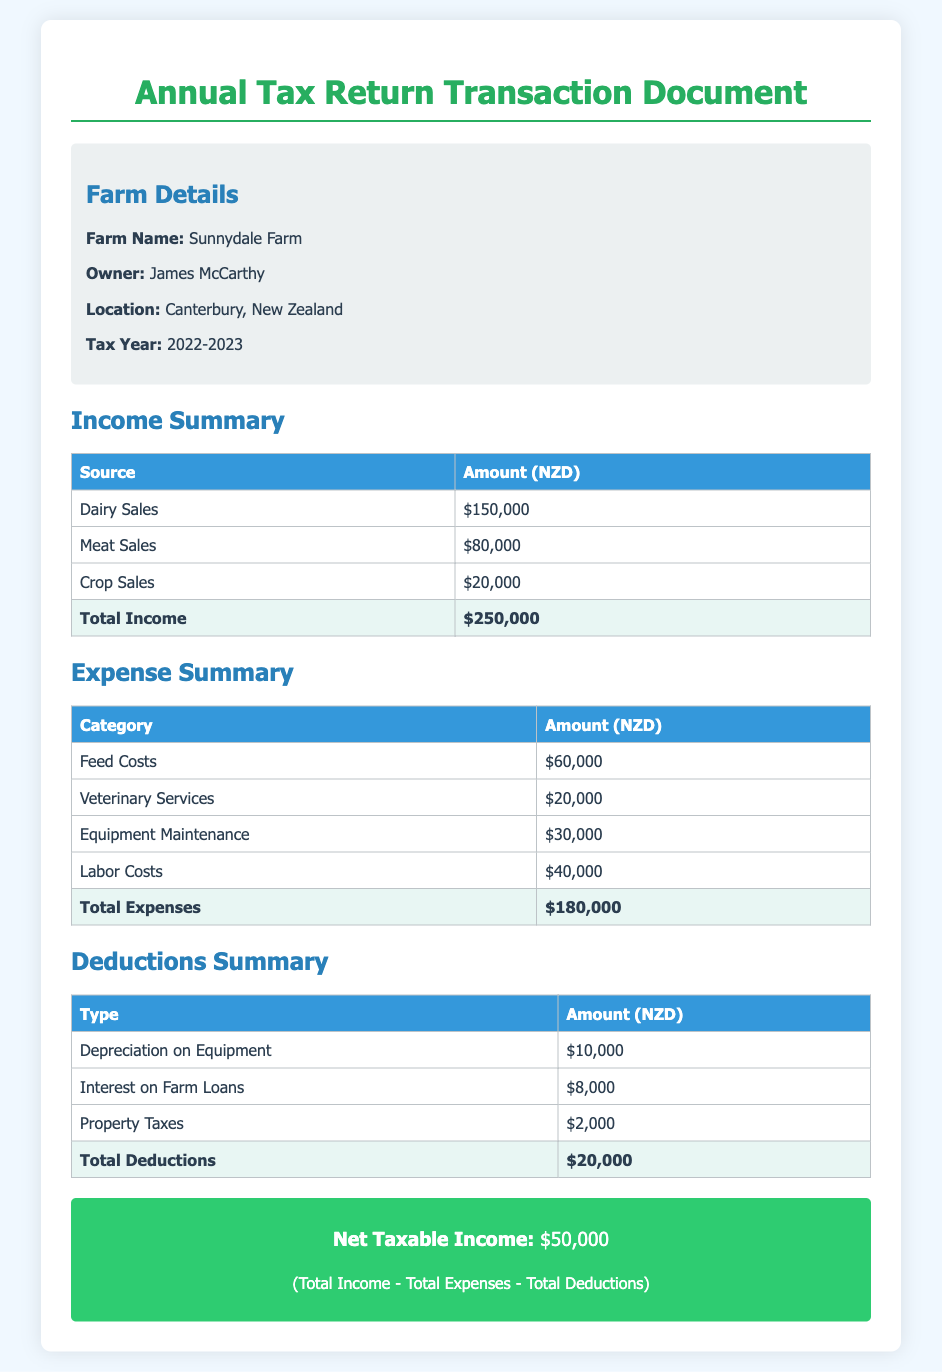What is the name of the farm? The farm's name is provided in the document under the farm details section.
Answer: Sunnydale Farm Who is the owner of the farm? The owner's name is listed in the farm details section of the document.
Answer: James McCarthy What is the total income of the farm? The total income is found in the income summary table, which adds up all income sources.
Answer: $250,000 What is the total amount spent on labor costs? The labor costs are specifically mentioned in the expense summary table.
Answer: $40,000 What is the total amount of deductions? The total deductions are detailed in the deductions summary table at the end of that section.
Answer: $20,000 What is the net taxable income? The net taxable income is calculated as Total Income minus Total Expenses minus Total Deductions. This is stated clearly in the document.
Answer: $50,000 How much was spent on veterinary services? The amount spent on veterinary services is specified in the expense summary table.
Answer: $20,000 What was the interest paid on farm loans? The interest on farm loans is provided in the deductions summary section of the document.
Answer: $8,000 Which year does the tax return cover? The tax year is mentioned in the farm details section at the beginning of the document.
Answer: 2022-2023 